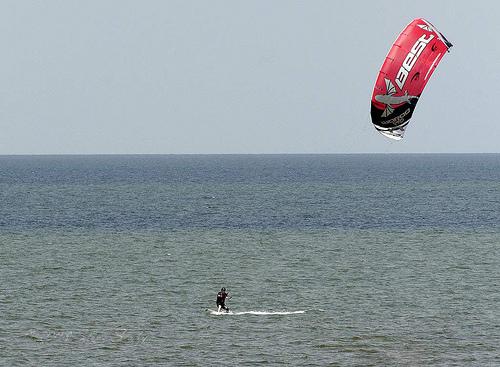What is this person doing?
Write a very short answer. Parasailing. Is this person too far from shore?
Short answer required. No. How many people are in the water?
Give a very brief answer. 1. 